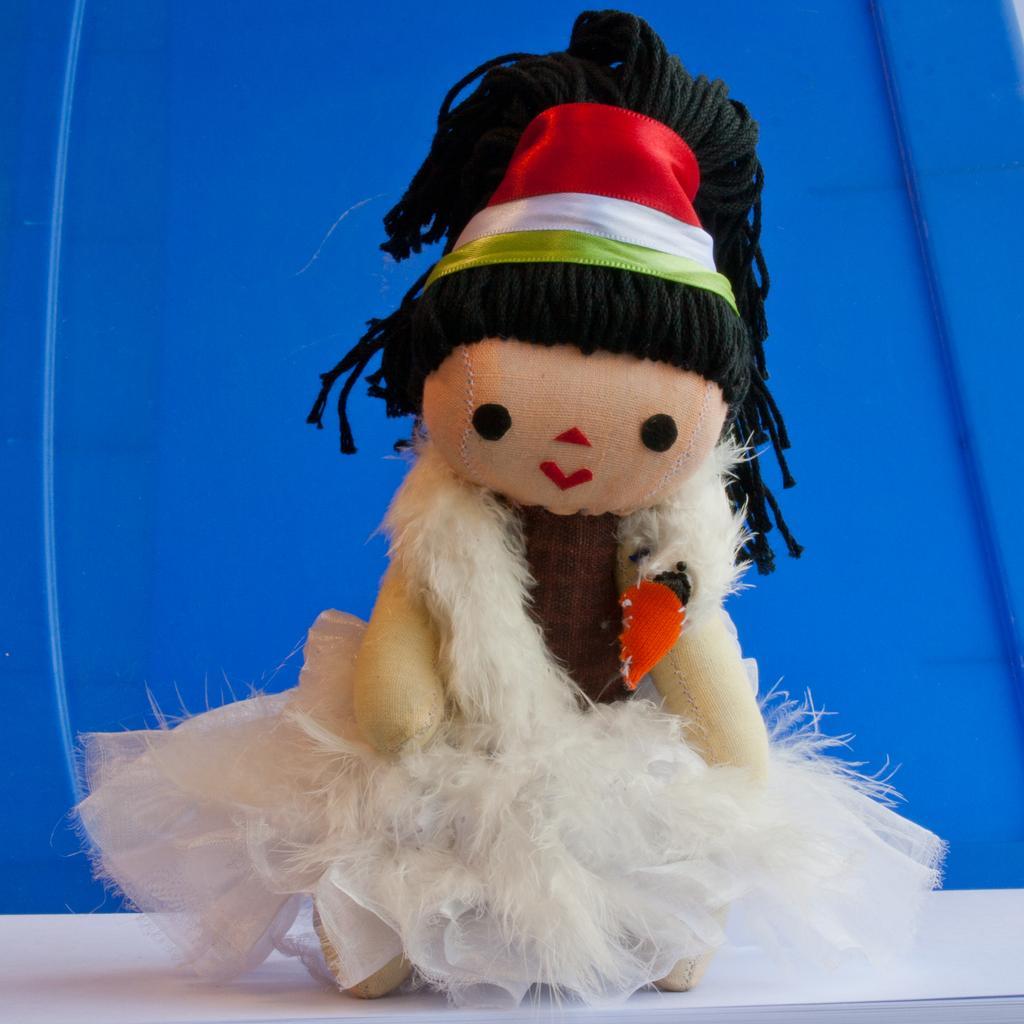Could you give a brief overview of what you see in this image? The picture consists of a doll on a white table. In the background there is a blue color object. 